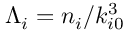Convert formula to latex. <formula><loc_0><loc_0><loc_500><loc_500>\Lambda _ { i } = n _ { i } / k _ { i 0 } ^ { 3 }</formula> 